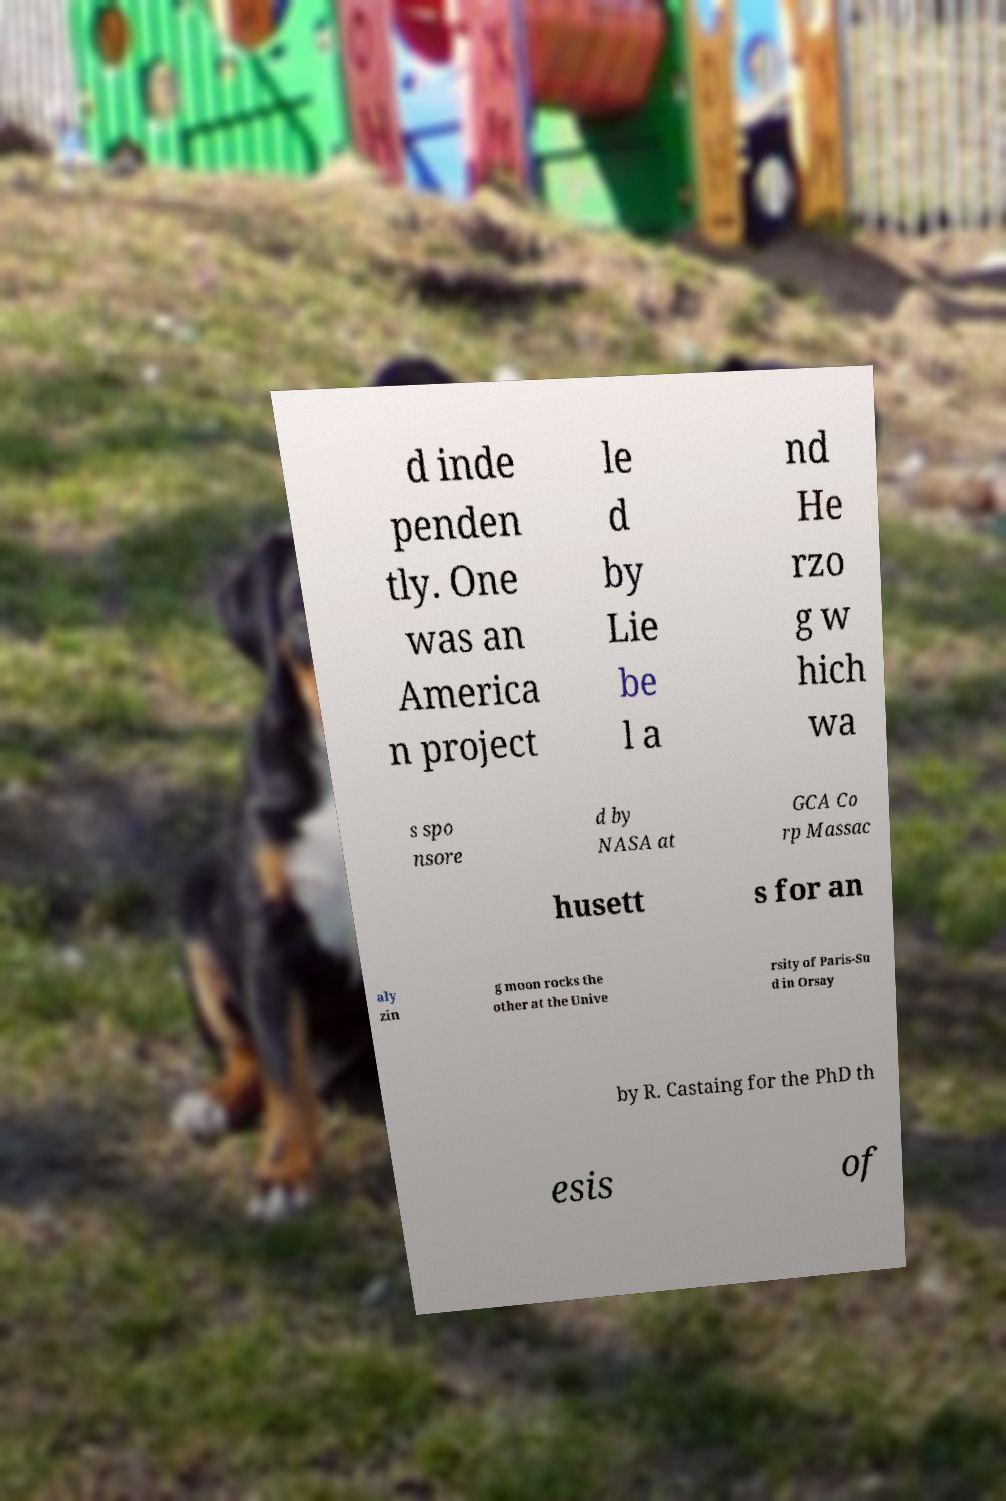Can you accurately transcribe the text from the provided image for me? d inde penden tly. One was an America n project le d by Lie be l a nd He rzo g w hich wa s spo nsore d by NASA at GCA Co rp Massac husett s for an aly zin g moon rocks the other at the Unive rsity of Paris-Su d in Orsay by R. Castaing for the PhD th esis of 